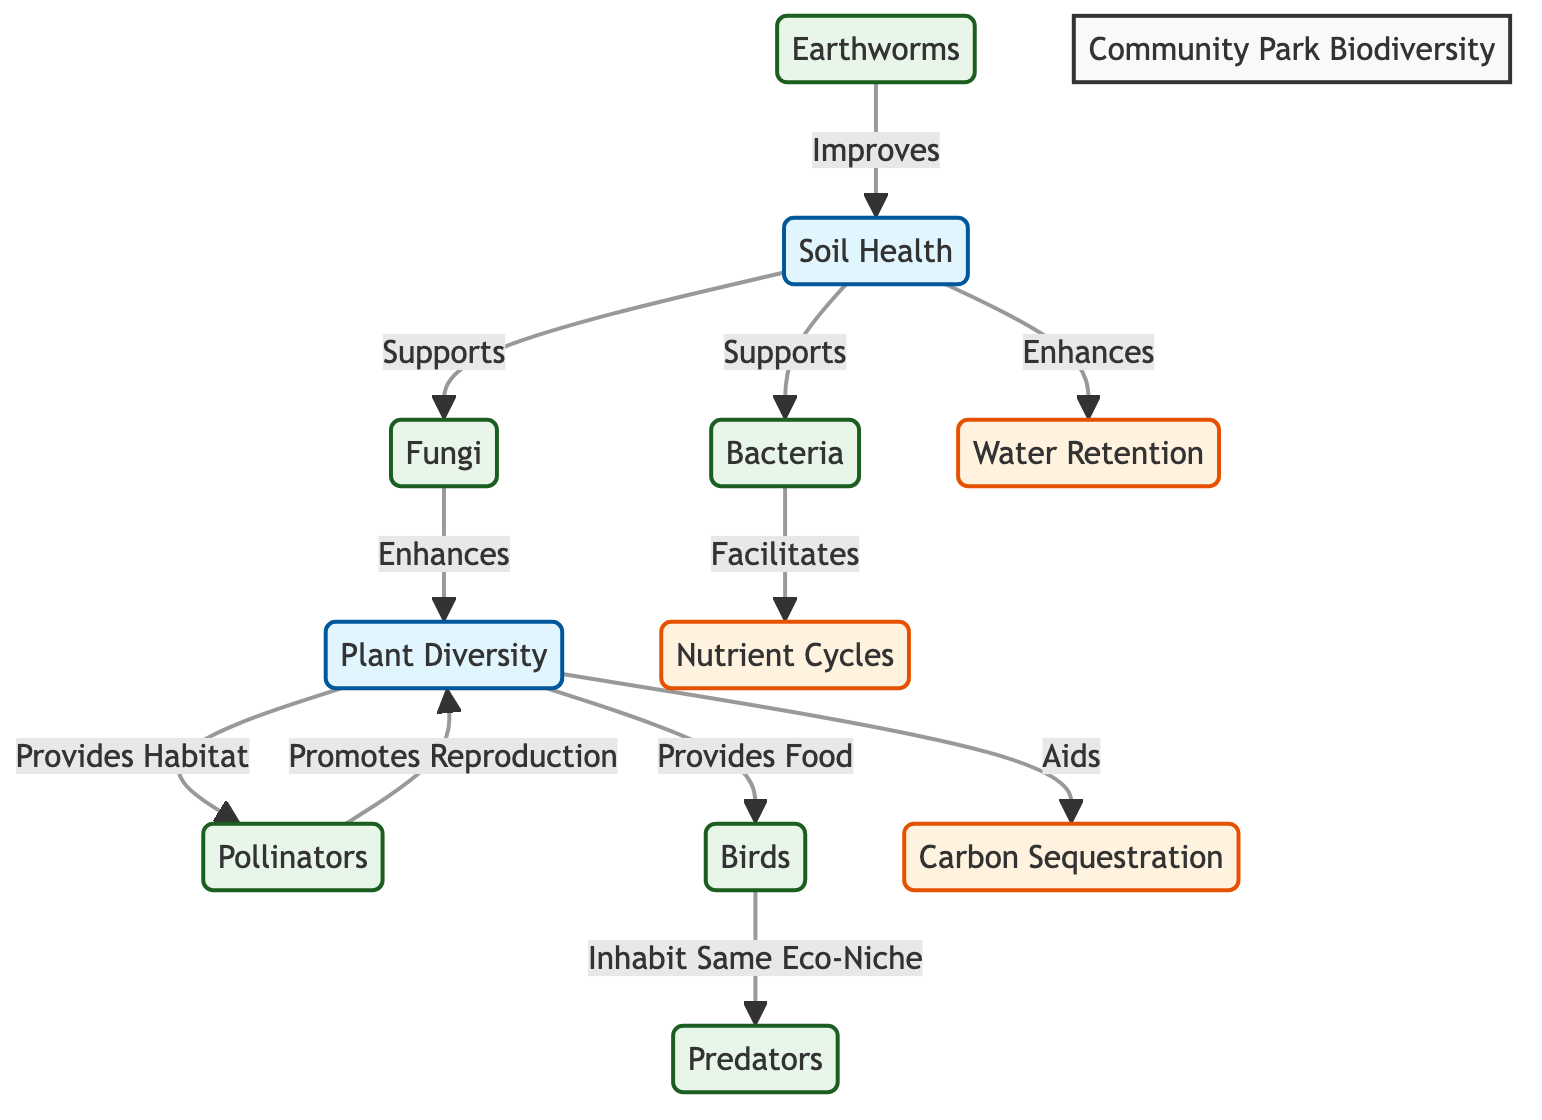What are the three organisms involved in enhancing soil health? The diagram shows that soil health is supported by fungi and bacteria, and earthworms improve soil health. By looking at the direct connections from the "Soil Health" node, we can identify these three organisms clearly.
Answer: Fungi, Bacteria, Earthworms How many processes are mentioned in the diagram? The diagram identifies three processes: nutrient cycles, carbon sequestration, and water retention. By counting the nodes labeled as processes, we can determine their number.
Answer: 3 Which organism promotes reproduction in plant diversity? The diagram indicates that pollinators promote reproduction in plant diversity. This relationship is specifically directed from the pollinators to the plant diversity node.
Answer: Pollinators What supports nutrient cycles according to the diagram? The diagram shows that bacteria facilitates nutrient cycles. This is identified by the directed relationship from the bacteria node to the nutrient cycles node.
Answer: Bacteria How does plant diversity affect carbon sequestration? The diagram illustrates that plant diversity aids carbon sequestration. This relationship is indicated by the directed edge from plant diversity to carbon sequestration.
Answer: Aids Which process is enhanced by soil health? The diagram specifies that water retention is enhanced by soil health. The directed relationship is clearly marked from the soil health node to the water retention node.
Answer: Water Retention What type of habitat does plant diversity provide? According to the diagram, plant diversity provides habitat for pollinators. This can be verified by observing the directed connection from plant diversity to the pollinators node.
Answer: Habitat How many organisms are shown in the community park biodiversity? The diagram lists six organisms: fungi, bacteria, earthworms, pollinators, birds, and predators. By counting all organism nodes, we arrive at the total.
Answer: 6 Which organism is indicated to inhabit the same eco-niche as predators? The diagram indicates that birds inhabit the same eco-niche as predators. This relationship is represented by the directed line connecting the birds node to the predators node.
Answer: Birds 